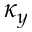Convert formula to latex. <formula><loc_0><loc_0><loc_500><loc_500>\kappa _ { y }</formula> 